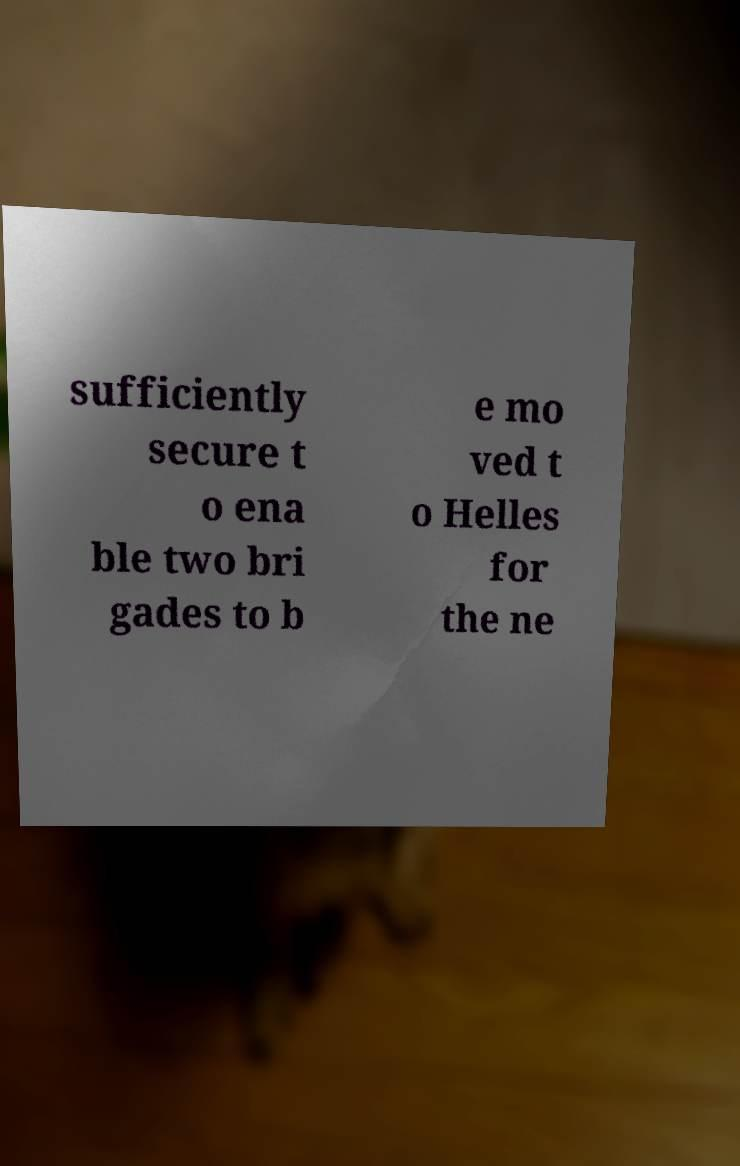There's text embedded in this image that I need extracted. Can you transcribe it verbatim? sufficiently secure t o ena ble two bri gades to b e mo ved t o Helles for the ne 